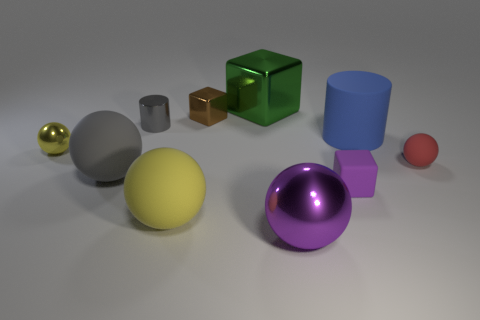There is a rubber ball that is the same color as the metal cylinder; what is its size? The rubber ball in question appears to be approximately the same size as the metal cylinder beside it, which seems to be small to medium size relative to the assorted objects in the image. 